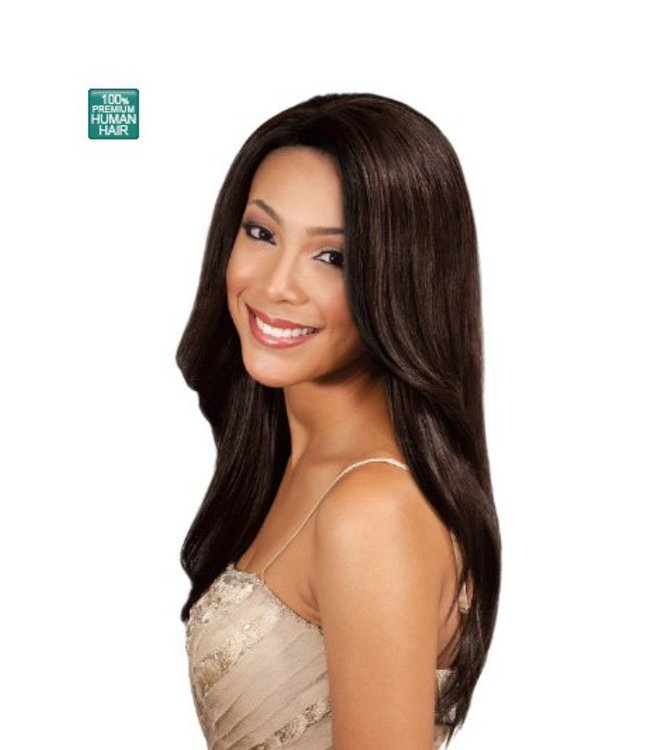Is this product suitable for people with sensitive scalps? Products made from 100% human hair, like the one in the image, are often more suitable for people with sensitive scalps compared to synthetic hair products. Human hair wigs are breathable and less likely to cause irritation or discomfort. However, it's always best to check any specific product details or consult with the retailer to ensure it meets your individual needs. How can I maintain the quality of 100% human hair products like this wig? To maintain the quality of 100% human hair products like this wig, follow these steps:
1. **Gently Brush:** Use a wide-tooth comb or a wig brush to gently detangle the hair before and after use.
2. **Wash Sparingly:** Wash the wig with a mild shampoo and lukewarm water every 7-10 wears, or as needed. Avoid harsh chemicals that can damage the hair.
3. **Condition:** Apply a good quality conditioner to keep the hair hydrated and maintain its softness.
4. **Dry Naturally:** Allow the wig to air dry on a wig stand. Avoid excessive heat from blow dryers or direct sunlight.
5. **Store Properly:** Store the wig on a wig stand or in its original packaging to retain its shape.
6. **Avoid Heat Styling:** Limit the use of heat styling tools like flat irons and curlers to prevent damage. 